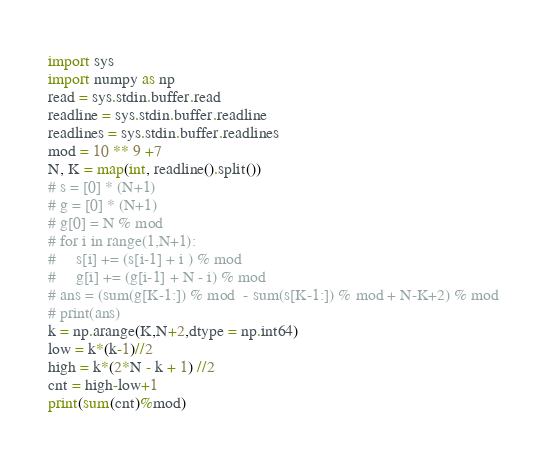<code> <loc_0><loc_0><loc_500><loc_500><_Python_>import sys 
import numpy as np
read = sys.stdin.buffer.read
readline = sys.stdin.buffer.readline
readlines = sys.stdin.buffer.readlines
mod = 10 ** 9 +7
N, K = map(int, readline().split())
# s = [0] * (N+1)
# g = [0] * (N+1)
# g[0] = N % mod
# for i in range(1,N+1):
#     s[i] += (s[i-1] + i ) % mod
#     g[i] += (g[i-1] + N - i) % mod
# ans = (sum(g[K-1:]) % mod  - sum(s[K-1:]) % mod + N-K+2) % mod
# print(ans)
k = np.arange(K,N+2,dtype = np.int64)
low = k*(k-1)//2
high = k*(2*N - k + 1) //2
cnt = high-low+1
print(sum(cnt)%mod)</code> 